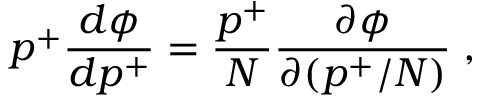Convert formula to latex. <formula><loc_0><loc_0><loc_500><loc_500>p ^ { + } \frac { d \phi } { d p ^ { + } } = \frac { p ^ { + } } { N } \frac { \partial \phi } { \partial ( p ^ { + } / N ) } \, ,</formula> 